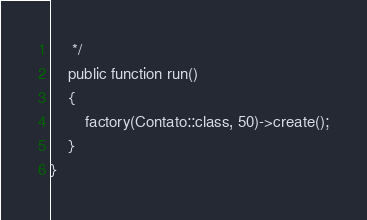Convert code to text. <code><loc_0><loc_0><loc_500><loc_500><_PHP_>     */
    public function run()
    {
        factory(Contato::class, 50)->create();
    }
}
</code> 